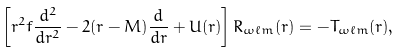<formula> <loc_0><loc_0><loc_500><loc_500>\left [ r ^ { 2 } f \frac { d ^ { 2 } } { d r ^ { 2 } } - 2 ( r - M ) \frac { d } { d r } + U ( r ) \right ] R _ { \omega \ell m } ( r ) = - T _ { \omega \ell m } ( r ) ,</formula> 